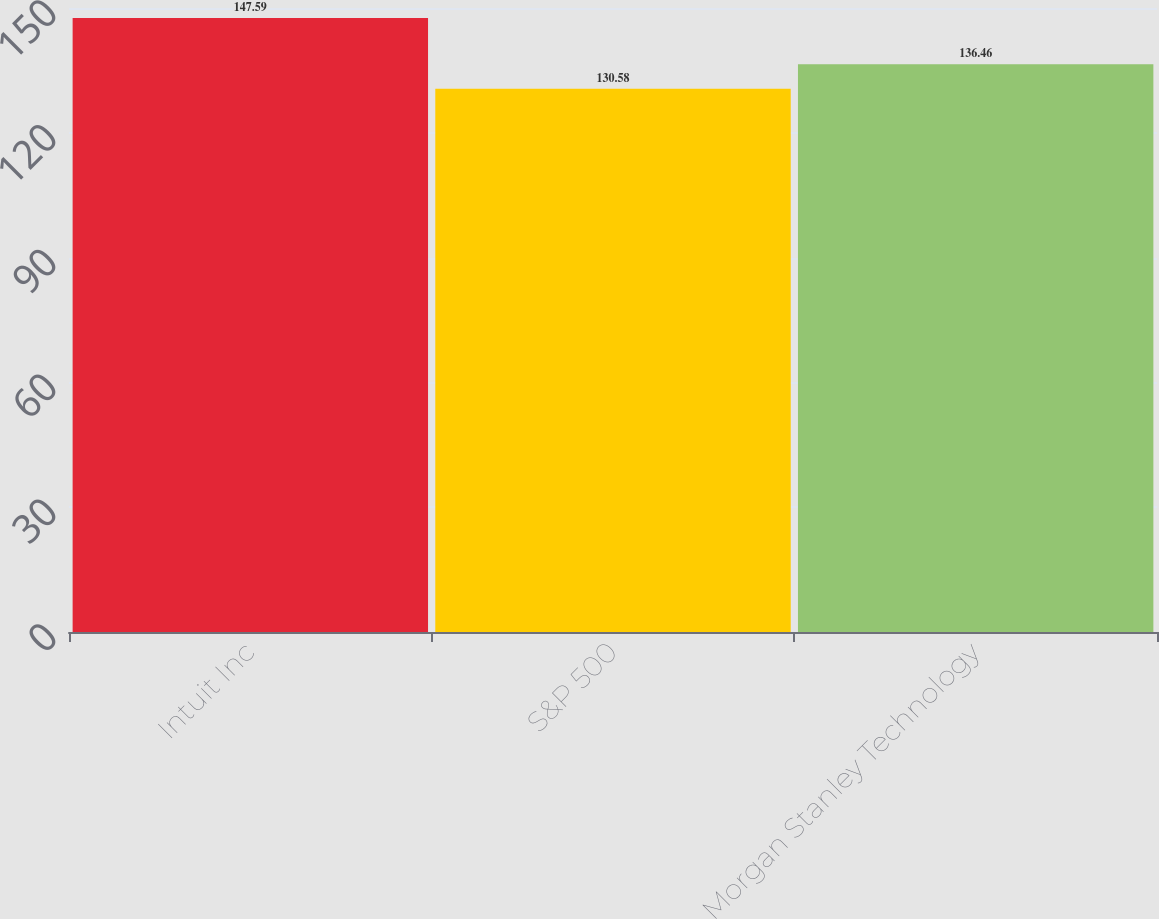Convert chart to OTSL. <chart><loc_0><loc_0><loc_500><loc_500><bar_chart><fcel>Intuit Inc<fcel>S&P 500<fcel>Morgan Stanley Technology<nl><fcel>147.59<fcel>130.58<fcel>136.46<nl></chart> 